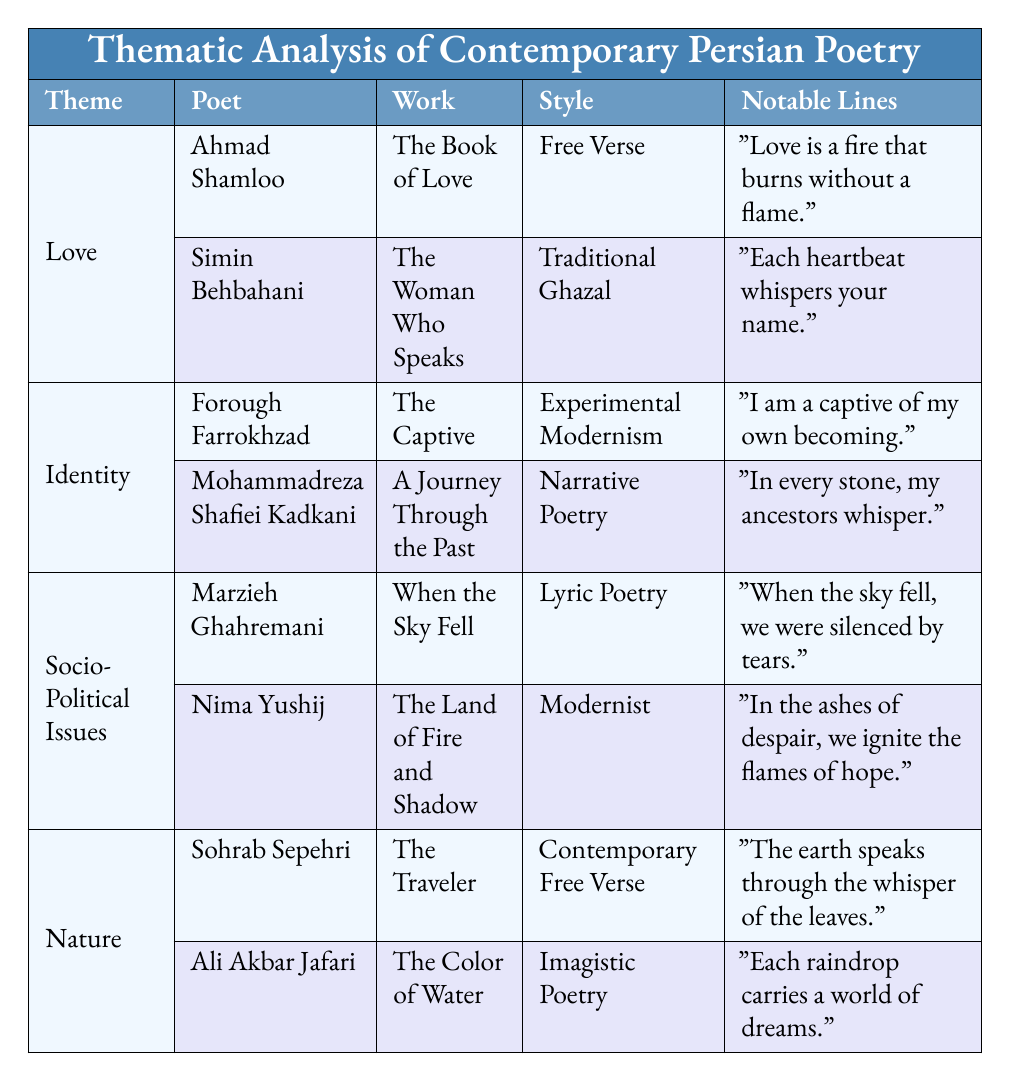What are the notable lines from Ahmad Shamloo's work? According to the table, Ahmad Shamloo's notable line from "The Book of Love" is "Love is a fire that burns without a flame."
Answer: "Love is a fire that burns without a flame." Which poet wrote about feminine identity? The table specifies that Forough Farrokhzad addressed feminine identity in her work "The Captive."
Answer: Forough Farrokhzad How many poets are associated with the theme of Socio-Political Issues? The table displays two poets under Socio-Political Issues: Marzieh Ghahremani and Nima Yushij, making the total count two.
Answer: 2 Which style is used by Simin Behbahani in her poem? According to the table, Simin Behbahani uses the Traditional Ghazal style in "The Woman Who Speaks."
Answer: Traditional Ghazal What subjects are covered in Sohrab Sepehri's poetry? As per the table, Sohrab Sepehri's poetry covers the subjects of "Harmony with Nature" and "Spirituality."
Answer: Harmony with Nature, Spirituality Who wrote a poem focusing on longing and connection? The table indicates that Ahmad Shamloo wrote "The Book of Love," which focuses on longing and connection.
Answer: Ahmad Shamloo In which work does Nima Yushij express themes of resistance and revolution? According to the table, Nima Yushij expresses these themes in "The Land of Fire and Shadow."
Answer: The Land of Fire and Shadow What is the poetic style of Mohammadreza Shafiei Kadkani? The table shows that Mohammadreza Shafiei Kadkani uses Narrative Poetry in his work "A Journey Through the Past."
Answer: Narrative Poetry Compare the styles of the poets writing about Nature. The table lists Sohrab Sepehri using Contemporary Free Verse and Ali Akbar Jafari using Imagistic Poetry, indicating two distinct styles.
Answer: Contemporary Free Verse, Imagistic Poetry Is it true that all poets listed in the table are modern poets? The table includes both modern poets and those using traditional styles; for example, Simin Behbahani uses Traditional Ghazal, so the statement is false.
Answer: No What is the notable line of Marzieh Ghahremani's poem? According to the table, Marzieh Ghahremani's notable line from "When the Sky Fell" is "When the sky fell, we were silenced by tears."
Answer: "When the sky fell, we were silenced by tears." How many subjects does Simin Behbahani address in her poetry? The table indicates that Simin Behbahani addresses two subjects: "Romantic Relationships" and "Emotional Bonding."
Answer: 2 Summarize the themes addressed by the poets in the table. The table outlines four themes: Love, Identity, Socio-Political Issues, and Nature, each with associated poets and their works addressing various aspects under these themes.
Answer: Love, Identity, Socio-Political Issues, Nature Which poet's work emphasizes cultural heritage and nostalgia? According to the table, Mohammadreza Shafiei Kadkani's poem "A Journey Through the Past" emphasizes cultural heritage and nostalgia.
Answer: Mohammadreza Shafiei Kadkani What is the total number of themes presented in the table? The table presents four themes: Love, Identity, Socio-Political Issues, and Nature, amounting to a total of four themes.
Answer: 4 